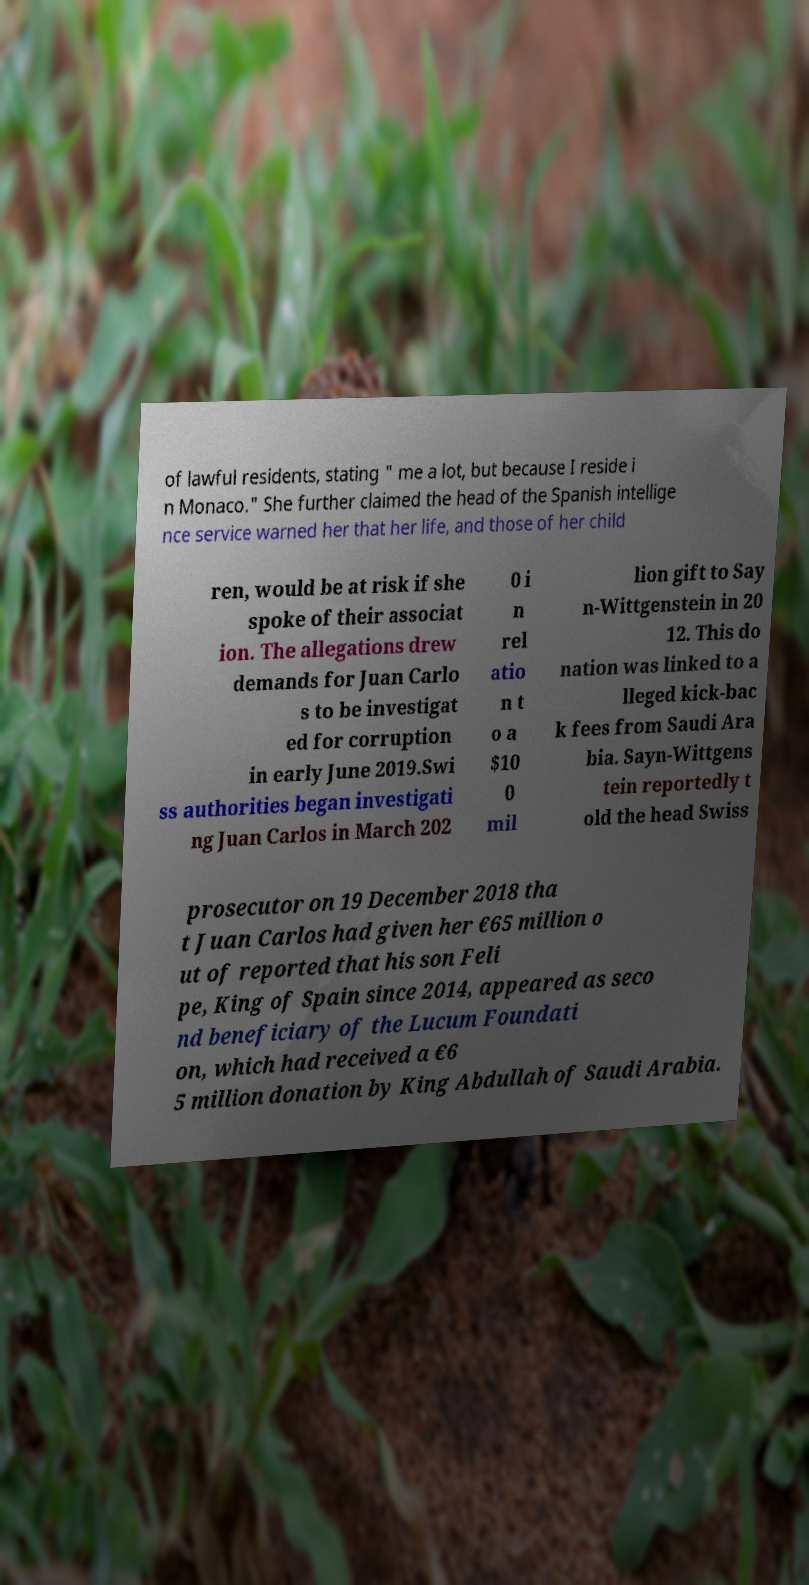Please identify and transcribe the text found in this image. of lawful residents, stating " me a lot, but because I reside i n Monaco." She further claimed the head of the Spanish intellige nce service warned her that her life, and those of her child ren, would be at risk if she spoke of their associat ion. The allegations drew demands for Juan Carlo s to be investigat ed for corruption in early June 2019.Swi ss authorities began investigati ng Juan Carlos in March 202 0 i n rel atio n t o a $10 0 mil lion gift to Say n-Wittgenstein in 20 12. This do nation was linked to a lleged kick-bac k fees from Saudi Ara bia. Sayn-Wittgens tein reportedly t old the head Swiss prosecutor on 19 December 2018 tha t Juan Carlos had given her €65 million o ut of reported that his son Feli pe, King of Spain since 2014, appeared as seco nd beneficiary of the Lucum Foundati on, which had received a €6 5 million donation by King Abdullah of Saudi Arabia. 